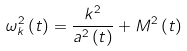<formula> <loc_0><loc_0><loc_500><loc_500>\omega _ { k } ^ { 2 } \left ( t \right ) = \frac { k ^ { 2 } } { a ^ { 2 } \left ( t \right ) } + M ^ { 2 } \left ( t \right )</formula> 